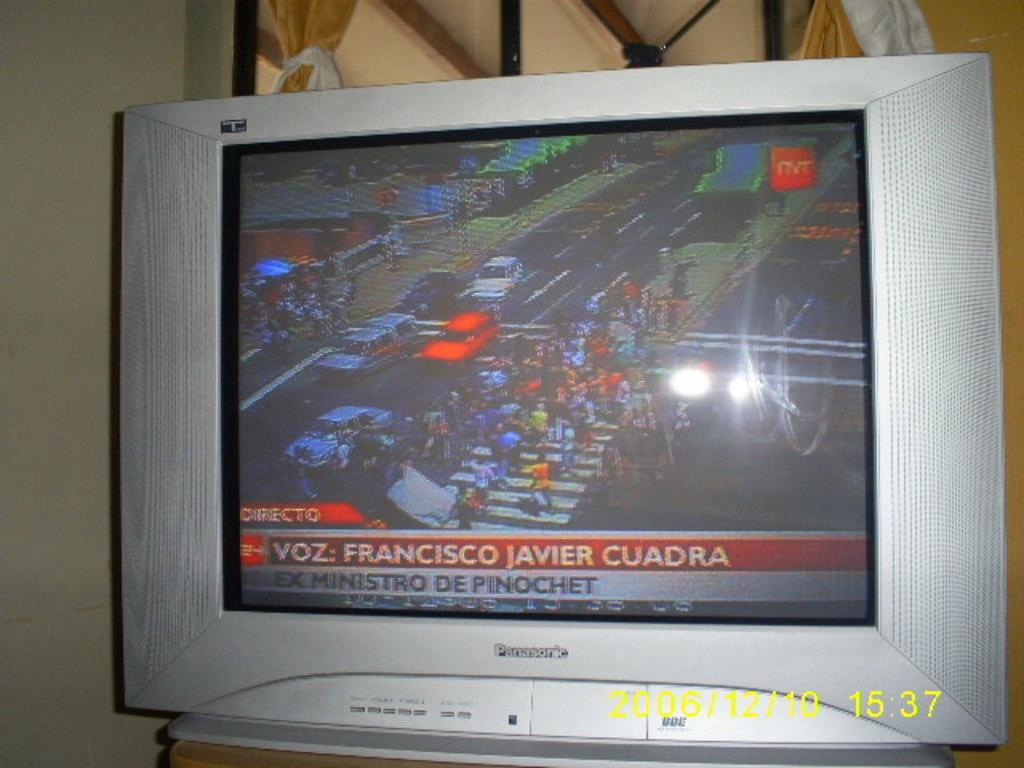<image>
Write a terse but informative summary of the picture. The Panasonic TV screen shows a news story about Francisco Javier Cuadra. 